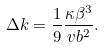Convert formula to latex. <formula><loc_0><loc_0><loc_500><loc_500>\Delta k = \frac { 1 } { 9 } \frac { \kappa \beta ^ { 3 } } { v b ^ { 2 } } .</formula> 